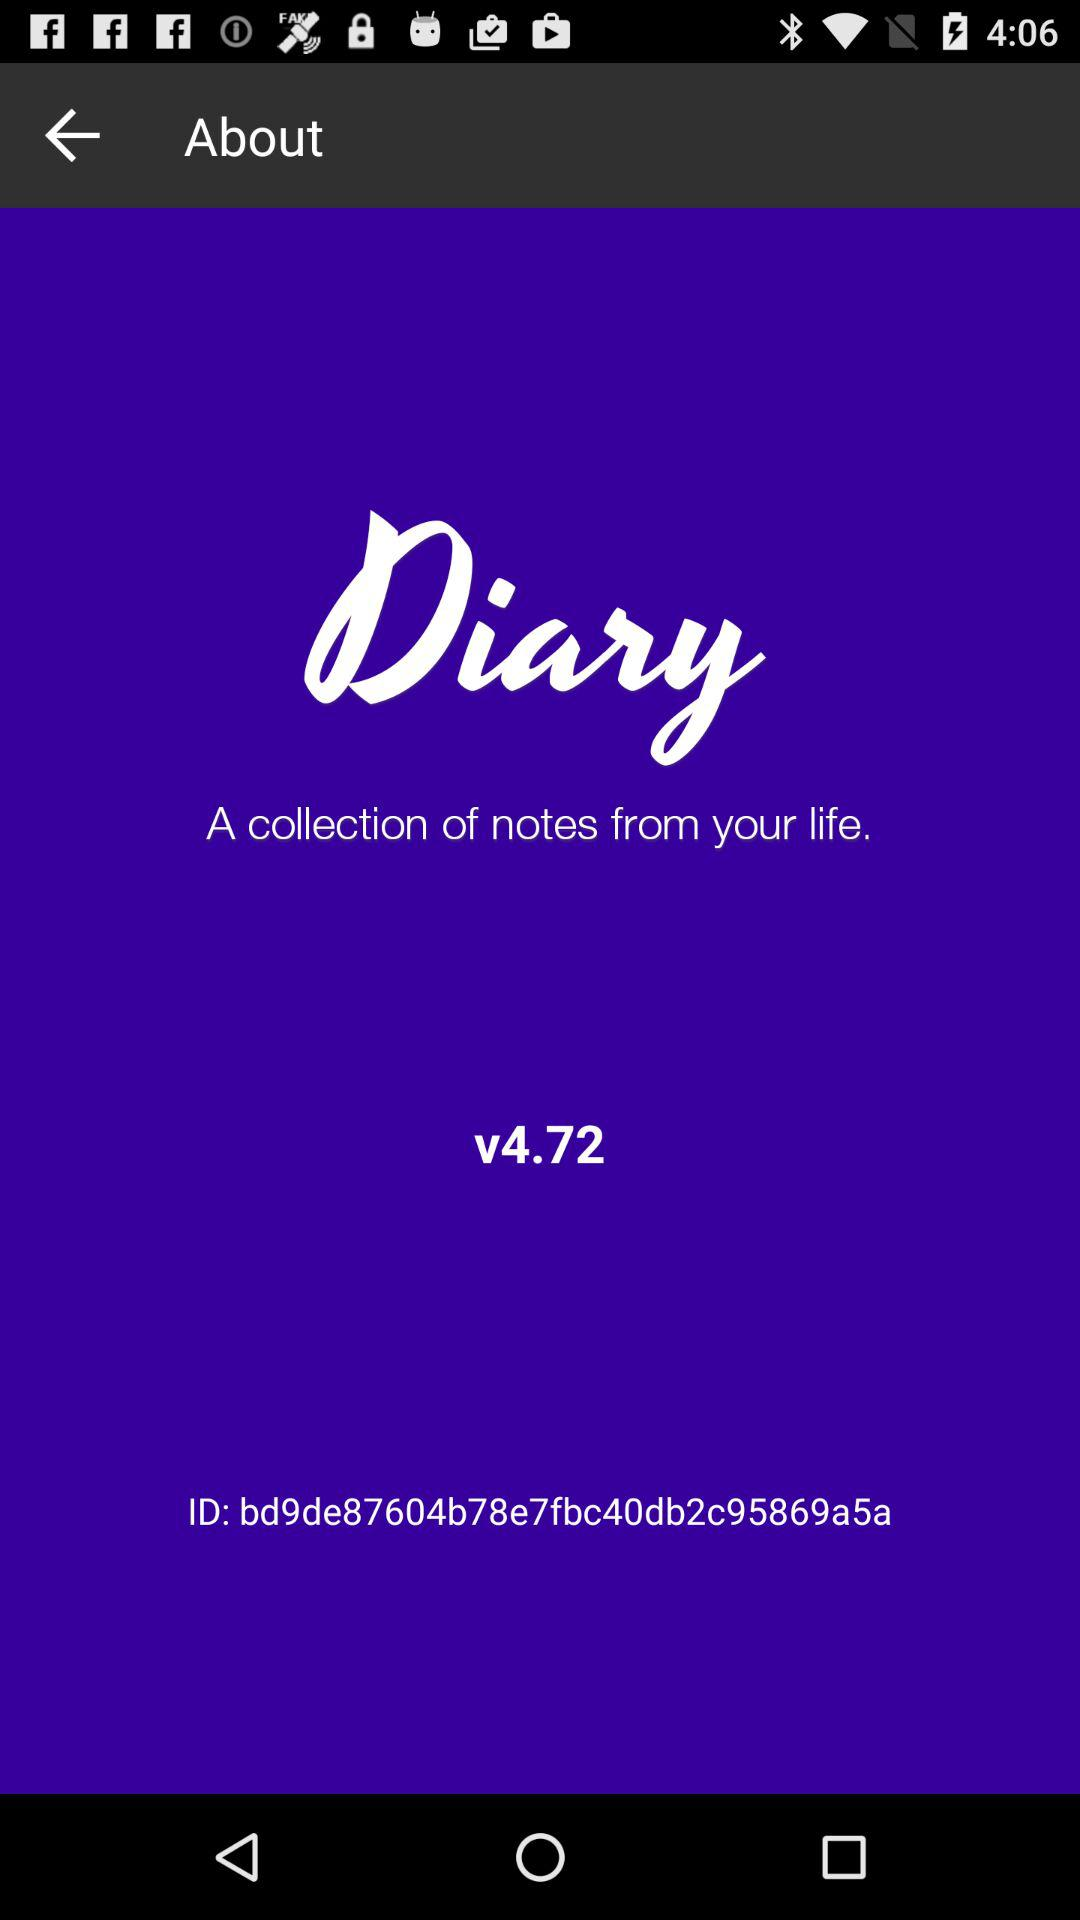What is the application name? The application name is "Diary". 